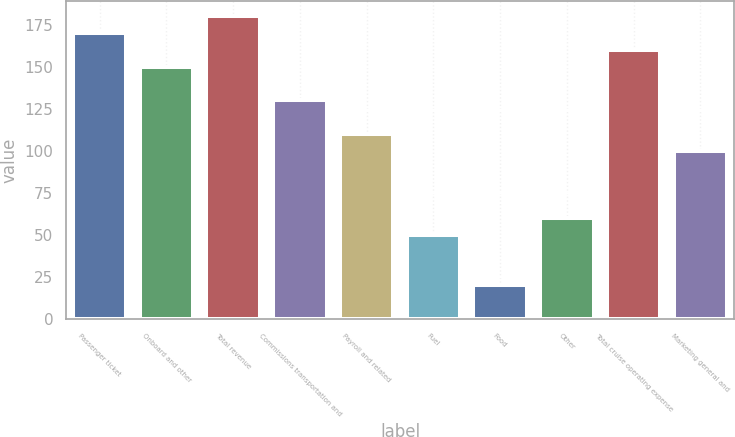Convert chart. <chart><loc_0><loc_0><loc_500><loc_500><bar_chart><fcel>Passenger ticket<fcel>Onboard and other<fcel>Total revenue<fcel>Commissions transportation and<fcel>Payroll and related<fcel>Fuel<fcel>Food<fcel>Other<fcel>Total cruise operating expense<fcel>Marketing general and<nl><fcel>169.86<fcel>149.9<fcel>179.84<fcel>129.94<fcel>109.98<fcel>50.1<fcel>20.16<fcel>60.08<fcel>159.88<fcel>100<nl></chart> 